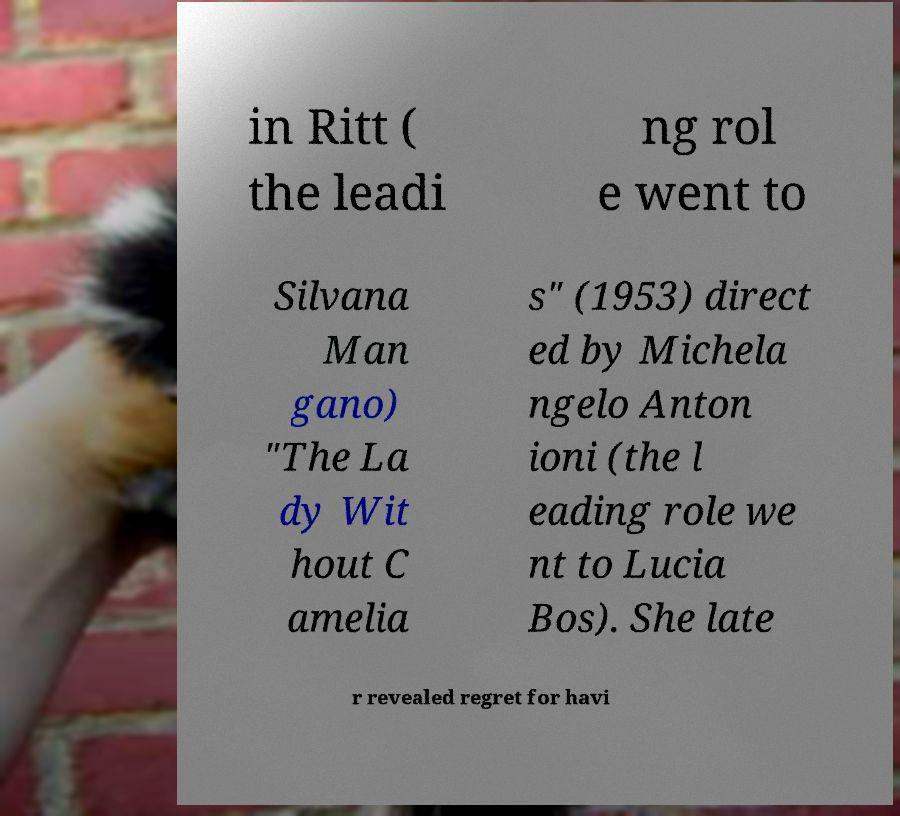Please identify and transcribe the text found in this image. in Ritt ( the leadi ng rol e went to Silvana Man gano) "The La dy Wit hout C amelia s" (1953) direct ed by Michela ngelo Anton ioni (the l eading role we nt to Lucia Bos). She late r revealed regret for havi 